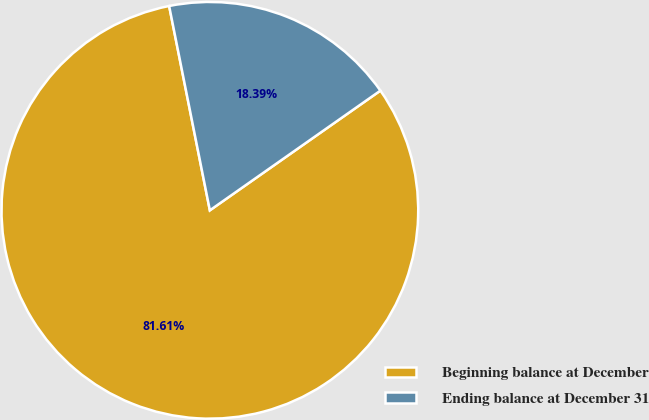Convert chart. <chart><loc_0><loc_0><loc_500><loc_500><pie_chart><fcel>Beginning balance at December<fcel>Ending balance at December 31<nl><fcel>81.61%<fcel>18.39%<nl></chart> 